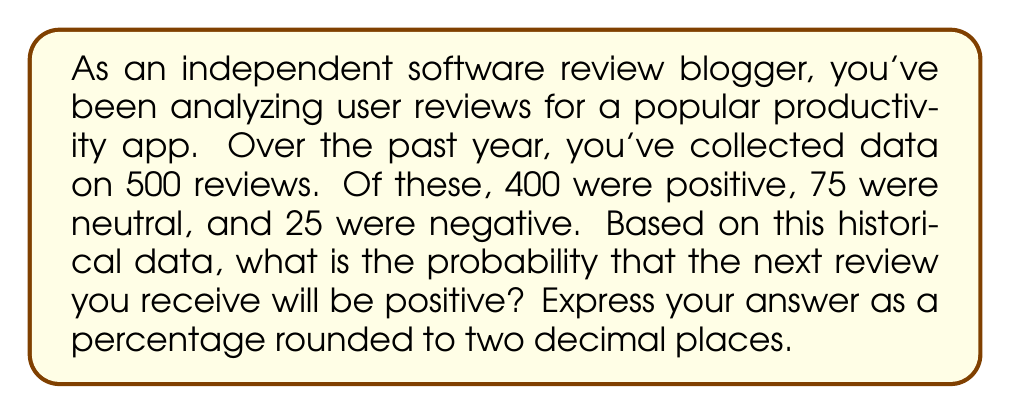What is the answer to this math problem? To solve this problem, we need to use the concept of probability based on historical data. The probability of an event occurring is calculated by dividing the number of favorable outcomes by the total number of possible outcomes.

Let's break down the given information:
- Total number of reviews: $500$
- Number of positive reviews: $400$
- Number of neutral reviews: $75$
- Number of negative reviews: $25$

To calculate the probability of a positive review:

1. Identify the number of favorable outcomes:
   Favorable outcomes = Number of positive reviews = $400$

2. Identify the total number of possible outcomes:
   Total possible outcomes = Total number of reviews = $500$

3. Calculate the probability using the formula:
   $$P(\text{positive review}) = \frac{\text{Number of positive reviews}}{\text{Total number of reviews}}$$

4. Plug in the values:
   $$P(\text{positive review}) = \frac{400}{500}$$

5. Simplify the fraction:
   $$P(\text{positive review}) = \frac{4}{5} = 0.8$$

6. Convert to a percentage:
   $$0.8 \times 100\% = 80\%$$

Therefore, based on the historical data, there is an 80% chance that the next review will be positive.
Answer: $80.00\%$ 